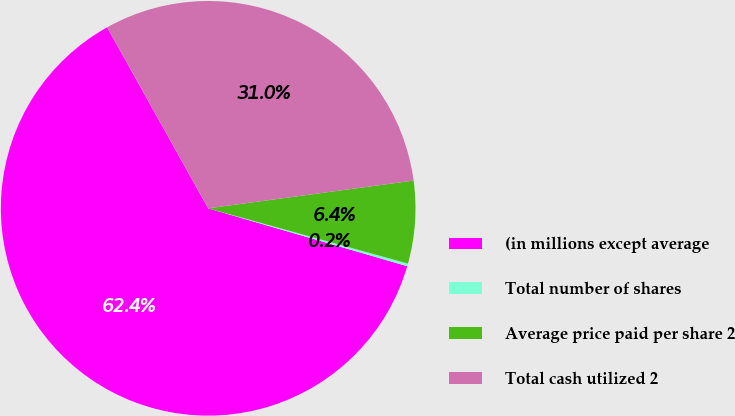Convert chart. <chart><loc_0><loc_0><loc_500><loc_500><pie_chart><fcel>(in millions except average<fcel>Total number of shares<fcel>Average price paid per share 2<fcel>Total cash utilized 2<nl><fcel>62.4%<fcel>0.21%<fcel>6.43%<fcel>30.97%<nl></chart> 